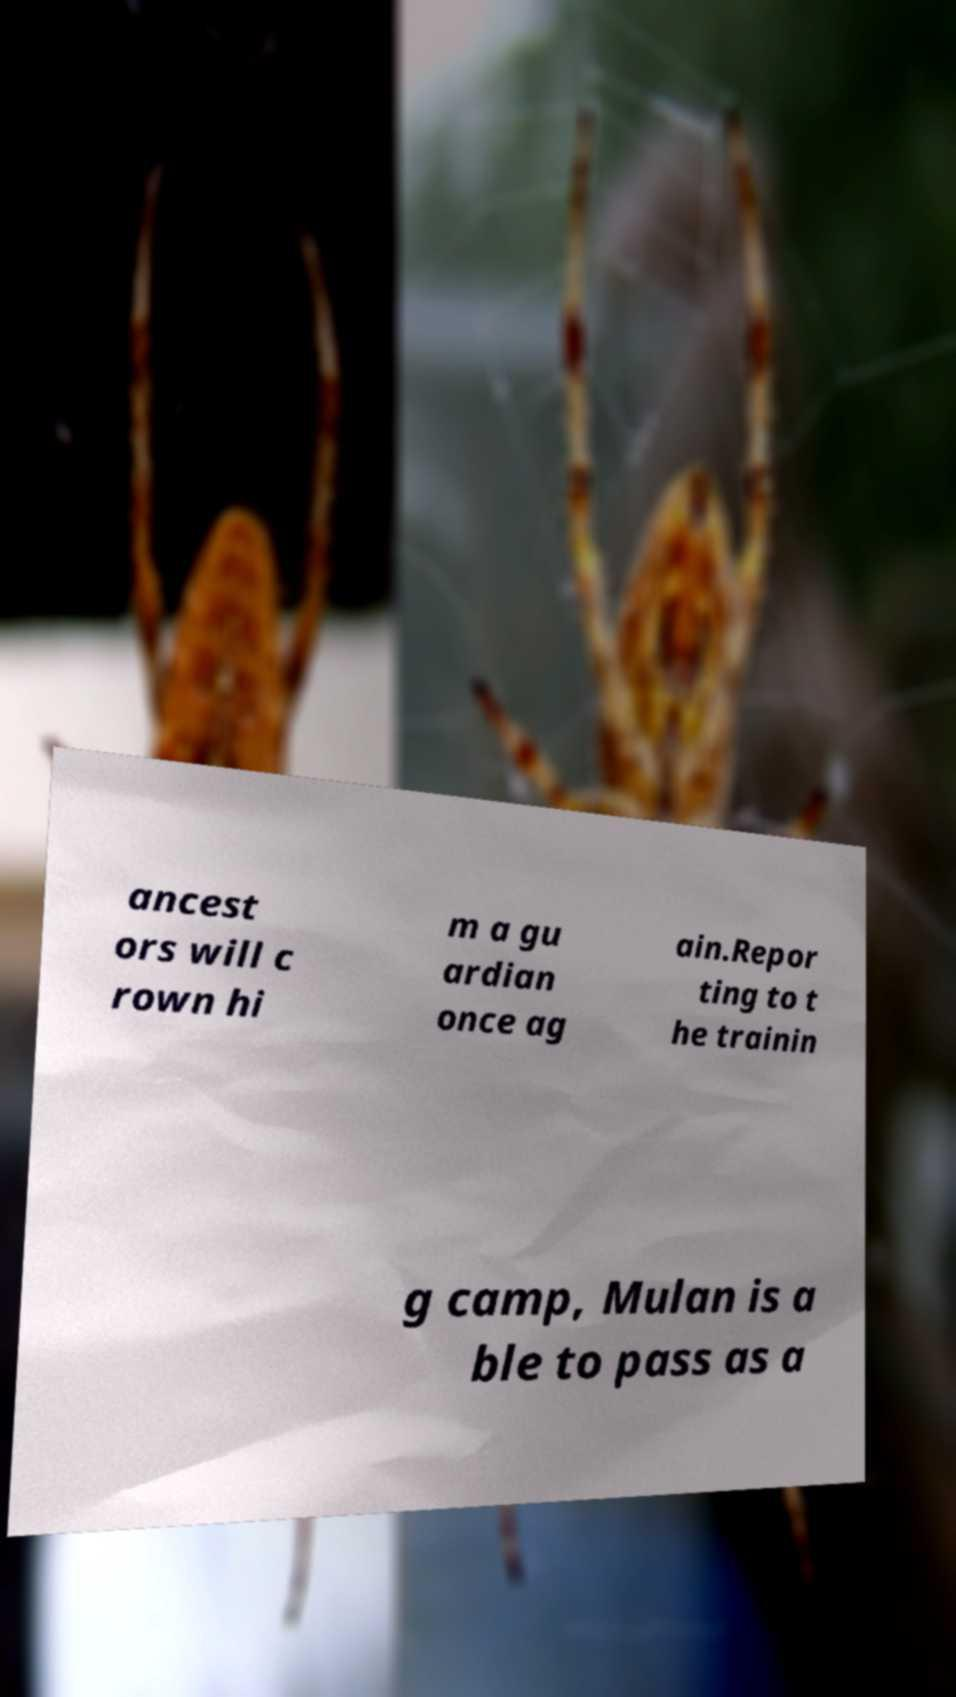Could you extract and type out the text from this image? ancest ors will c rown hi m a gu ardian once ag ain.Repor ting to t he trainin g camp, Mulan is a ble to pass as a 